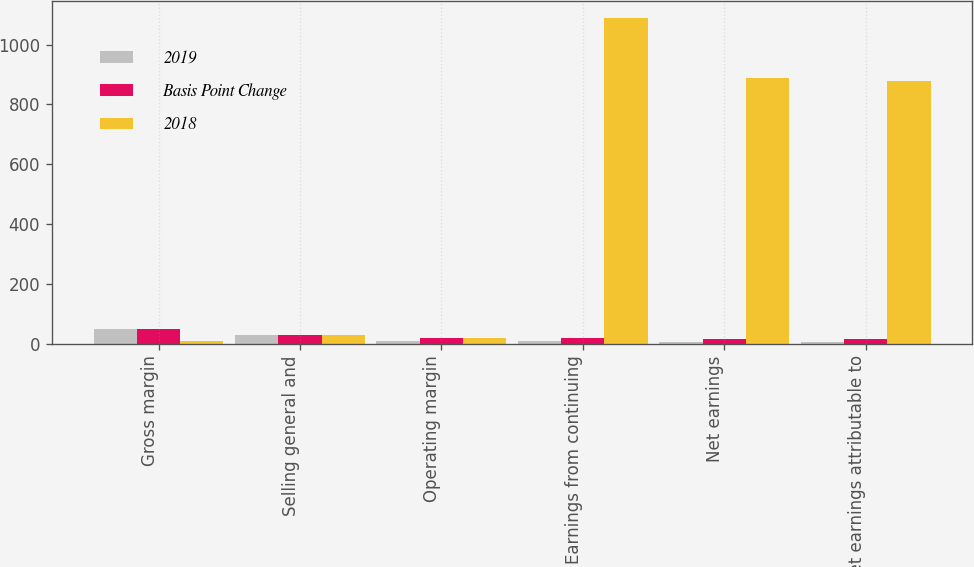Convert chart. <chart><loc_0><loc_0><loc_500><loc_500><stacked_bar_chart><ecel><fcel>Gross margin<fcel>Selling general and<fcel>Operating margin<fcel>Earnings from continuing<fcel>Net earnings<fcel>Net earnings attributable to<nl><fcel>2019<fcel>48.6<fcel>28.2<fcel>8.1<fcel>9<fcel>5.9<fcel>5.8<nl><fcel>Basis Point Change<fcel>48.5<fcel>28.5<fcel>20<fcel>19.9<fcel>14.8<fcel>14.6<nl><fcel>2018<fcel>10<fcel>30<fcel>20<fcel>1090<fcel>890<fcel>880<nl></chart> 